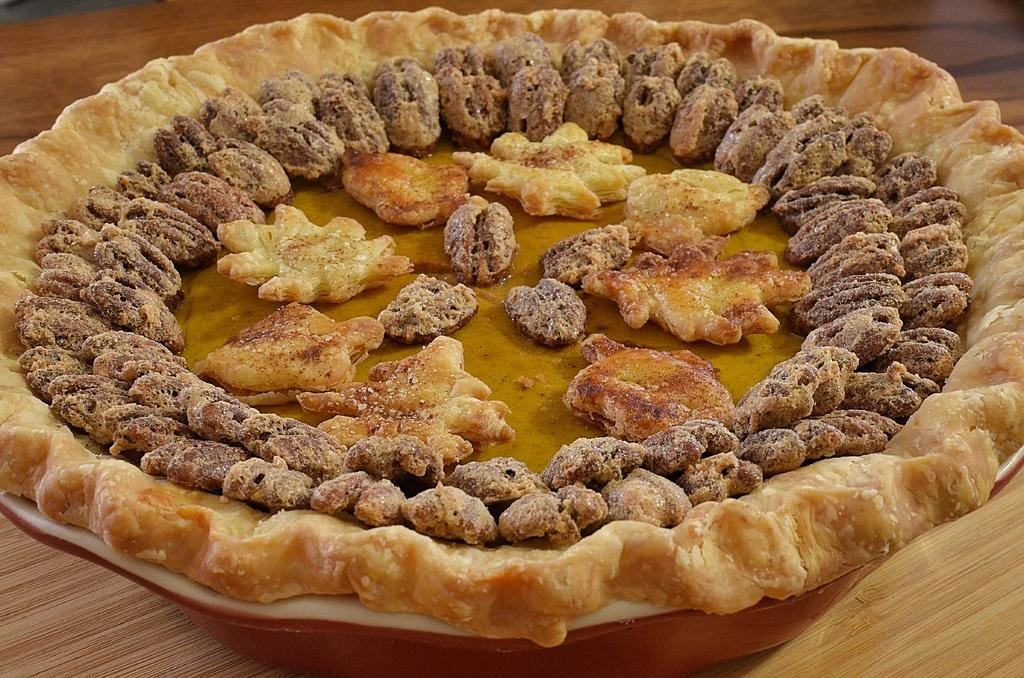What type of food can be seen in the image? The food in the image is in cream and brown colors. How is the food arranged in the image? The food is in a plate. What color is the plate? The plate is white. Is there a cat sleeping on the sheet in the image? There is no sheet or cat present in the image; it only features food in a plate. 